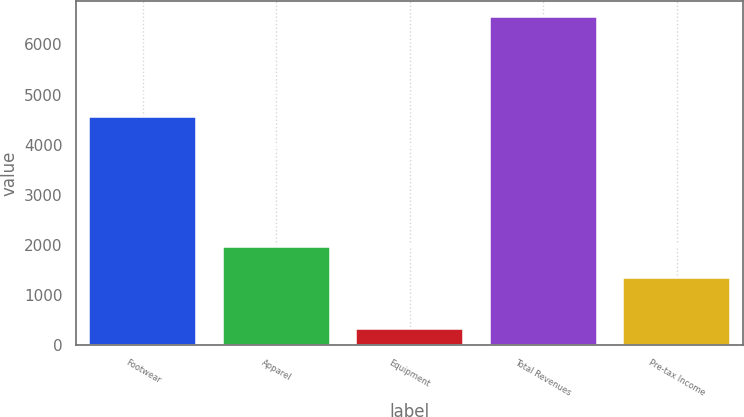<chart> <loc_0><loc_0><loc_500><loc_500><bar_chart><fcel>Footwear<fcel>Apparel<fcel>Equipment<fcel>Total Revenues<fcel>Pre-tax Income<nl><fcel>4550.8<fcel>1959.42<fcel>327.7<fcel>6542.9<fcel>1337.9<nl></chart> 